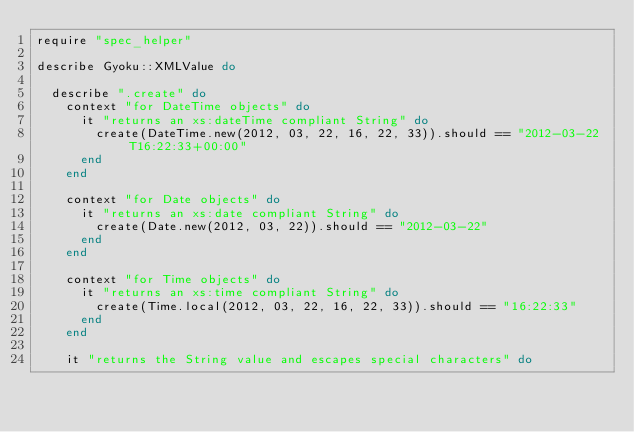Convert code to text. <code><loc_0><loc_0><loc_500><loc_500><_Ruby_>require "spec_helper"

describe Gyoku::XMLValue do

  describe ".create" do
    context "for DateTime objects" do
      it "returns an xs:dateTime compliant String" do
        create(DateTime.new(2012, 03, 22, 16, 22, 33)).should == "2012-03-22T16:22:33+00:00"
      end
    end

    context "for Date objects" do
      it "returns an xs:date compliant String" do
        create(Date.new(2012, 03, 22)).should == "2012-03-22"
      end
    end

    context "for Time objects" do
      it "returns an xs:time compliant String" do
        create(Time.local(2012, 03, 22, 16, 22, 33)).should == "16:22:33"
      end
    end

    it "returns the String value and escapes special characters" do</code> 